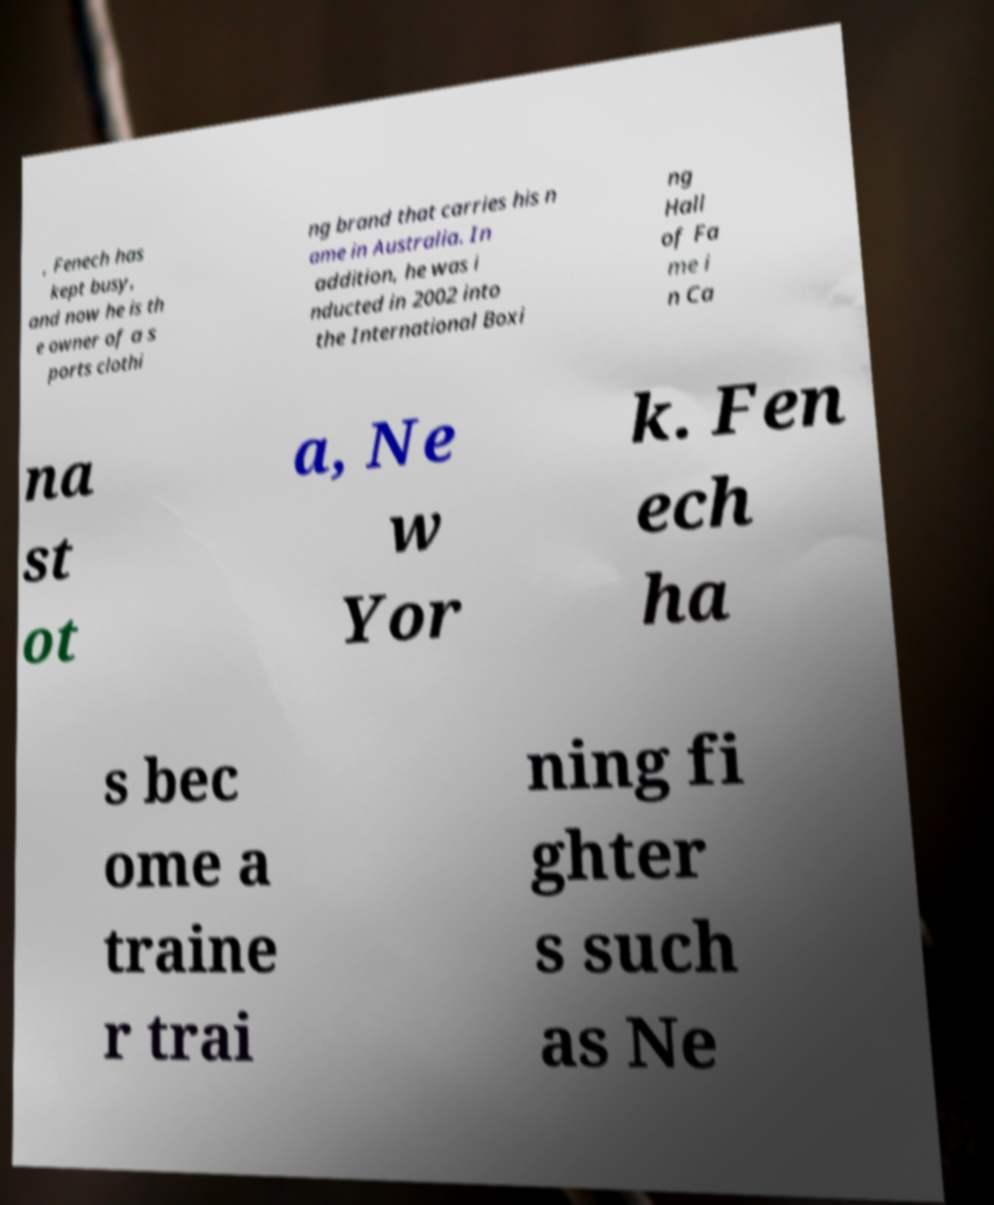Can you read and provide the text displayed in the image?This photo seems to have some interesting text. Can you extract and type it out for me? , Fenech has kept busy, and now he is th e owner of a s ports clothi ng brand that carries his n ame in Australia. In addition, he was i nducted in 2002 into the International Boxi ng Hall of Fa me i n Ca na st ot a, Ne w Yor k. Fen ech ha s bec ome a traine r trai ning fi ghter s such as Ne 